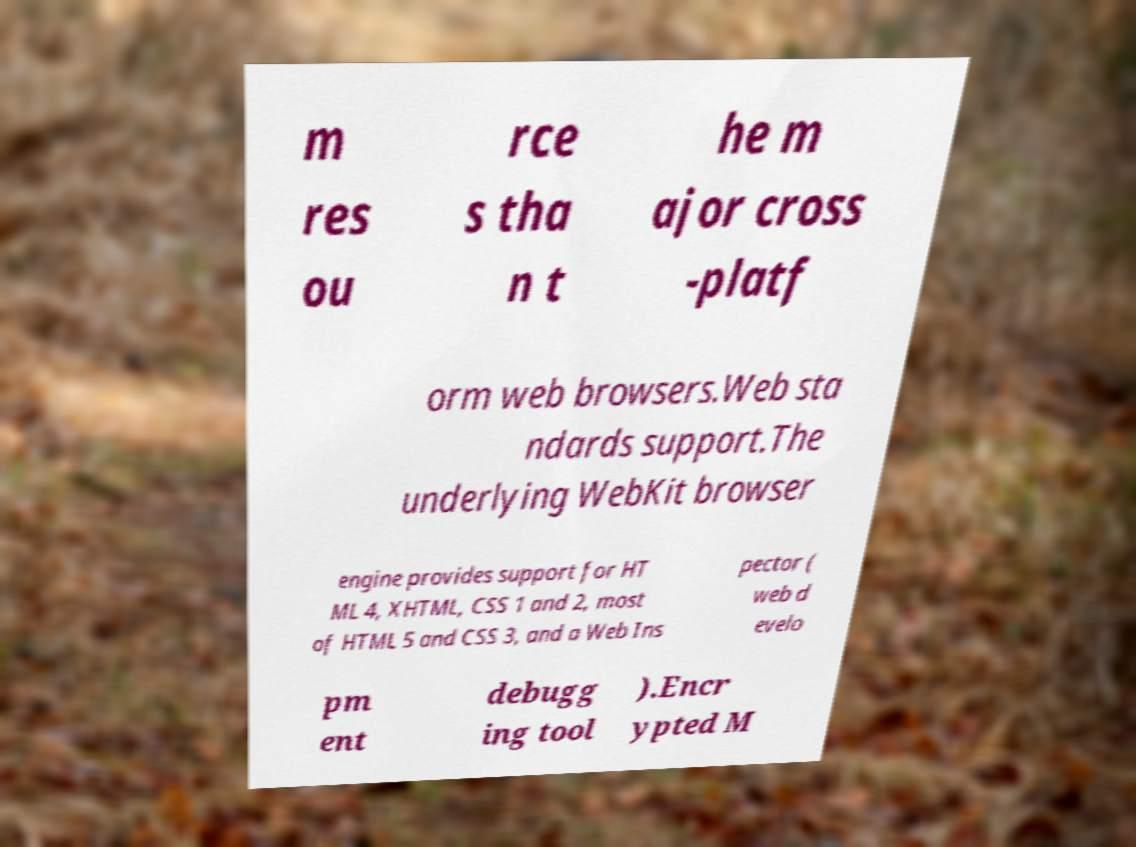What messages or text are displayed in this image? I need them in a readable, typed format. m res ou rce s tha n t he m ajor cross -platf orm web browsers.Web sta ndards support.The underlying WebKit browser engine provides support for HT ML 4, XHTML, CSS 1 and 2, most of HTML 5 and CSS 3, and a Web Ins pector ( web d evelo pm ent debugg ing tool ).Encr ypted M 